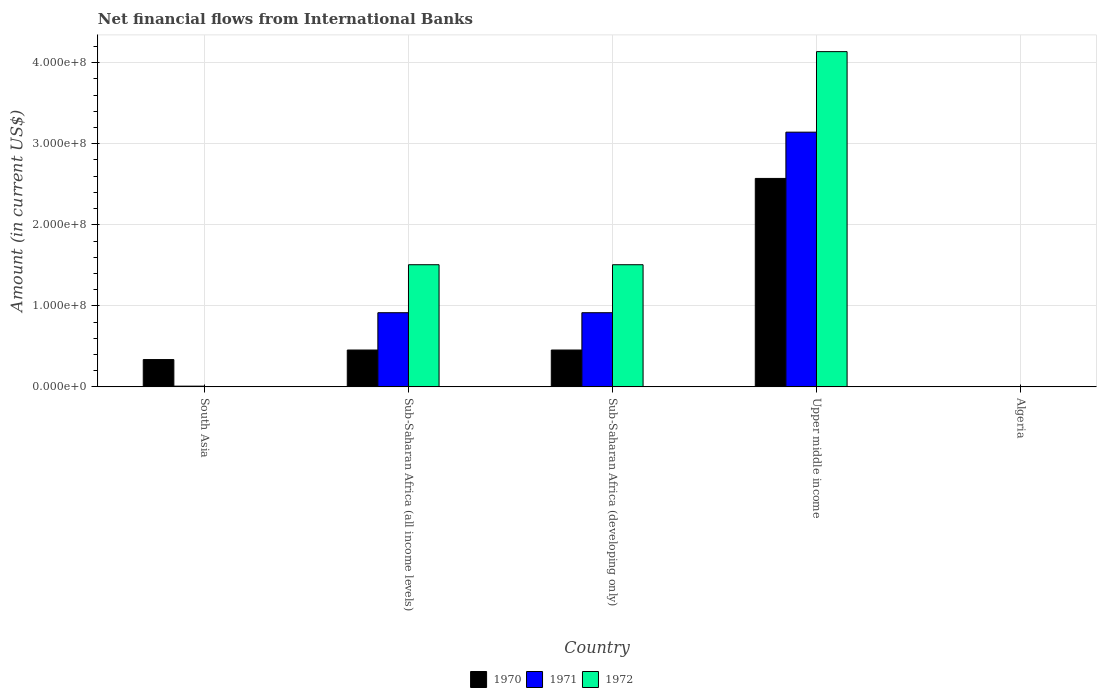How many different coloured bars are there?
Give a very brief answer. 3. Are the number of bars on each tick of the X-axis equal?
Provide a succinct answer. No. How many bars are there on the 1st tick from the left?
Offer a terse response. 2. How many bars are there on the 1st tick from the right?
Your response must be concise. 0. What is the label of the 4th group of bars from the left?
Your answer should be compact. Upper middle income. What is the net financial aid flows in 1971 in Algeria?
Ensure brevity in your answer.  0. Across all countries, what is the maximum net financial aid flows in 1972?
Make the answer very short. 4.14e+08. In which country was the net financial aid flows in 1971 maximum?
Provide a short and direct response. Upper middle income. What is the total net financial aid flows in 1972 in the graph?
Offer a terse response. 7.15e+08. What is the difference between the net financial aid flows in 1970 in South Asia and that in Sub-Saharan Africa (all income levels)?
Give a very brief answer. -1.18e+07. What is the difference between the net financial aid flows in 1970 in Algeria and the net financial aid flows in 1971 in Sub-Saharan Africa (developing only)?
Make the answer very short. -9.15e+07. What is the average net financial aid flows in 1970 per country?
Your answer should be compact. 7.64e+07. What is the difference between the net financial aid flows of/in 1971 and net financial aid flows of/in 1972 in Sub-Saharan Africa (all income levels)?
Offer a very short reply. -5.92e+07. What is the ratio of the net financial aid flows in 1972 in Sub-Saharan Africa (all income levels) to that in Upper middle income?
Provide a succinct answer. 0.36. What is the difference between the highest and the second highest net financial aid flows in 1972?
Offer a very short reply. 2.63e+08. What is the difference between the highest and the lowest net financial aid flows in 1972?
Provide a succinct answer. 4.14e+08. Is it the case that in every country, the sum of the net financial aid flows in 1970 and net financial aid flows in 1971 is greater than the net financial aid flows in 1972?
Your answer should be compact. No. How many bars are there?
Your answer should be compact. 11. Are all the bars in the graph horizontal?
Offer a very short reply. No. What is the difference between two consecutive major ticks on the Y-axis?
Ensure brevity in your answer.  1.00e+08. Are the values on the major ticks of Y-axis written in scientific E-notation?
Offer a very short reply. Yes. Where does the legend appear in the graph?
Offer a very short reply. Bottom center. How are the legend labels stacked?
Ensure brevity in your answer.  Horizontal. What is the title of the graph?
Make the answer very short. Net financial flows from International Banks. Does "1973" appear as one of the legend labels in the graph?
Ensure brevity in your answer.  No. What is the label or title of the Y-axis?
Keep it short and to the point. Amount (in current US$). What is the Amount (in current US$) of 1970 in South Asia?
Provide a succinct answer. 3.37e+07. What is the Amount (in current US$) of 1971 in South Asia?
Your answer should be very brief. 8.91e+05. What is the Amount (in current US$) in 1970 in Sub-Saharan Africa (all income levels)?
Provide a succinct answer. 4.55e+07. What is the Amount (in current US$) of 1971 in Sub-Saharan Africa (all income levels)?
Offer a very short reply. 9.15e+07. What is the Amount (in current US$) in 1972 in Sub-Saharan Africa (all income levels)?
Make the answer very short. 1.51e+08. What is the Amount (in current US$) in 1970 in Sub-Saharan Africa (developing only)?
Your response must be concise. 4.55e+07. What is the Amount (in current US$) of 1971 in Sub-Saharan Africa (developing only)?
Keep it short and to the point. 9.15e+07. What is the Amount (in current US$) of 1972 in Sub-Saharan Africa (developing only)?
Your answer should be compact. 1.51e+08. What is the Amount (in current US$) in 1970 in Upper middle income?
Give a very brief answer. 2.57e+08. What is the Amount (in current US$) in 1971 in Upper middle income?
Your response must be concise. 3.14e+08. What is the Amount (in current US$) in 1972 in Upper middle income?
Your response must be concise. 4.14e+08. Across all countries, what is the maximum Amount (in current US$) in 1970?
Give a very brief answer. 2.57e+08. Across all countries, what is the maximum Amount (in current US$) in 1971?
Your answer should be very brief. 3.14e+08. Across all countries, what is the maximum Amount (in current US$) of 1972?
Provide a succinct answer. 4.14e+08. What is the total Amount (in current US$) in 1970 in the graph?
Your response must be concise. 3.82e+08. What is the total Amount (in current US$) of 1971 in the graph?
Your response must be concise. 4.98e+08. What is the total Amount (in current US$) in 1972 in the graph?
Offer a terse response. 7.15e+08. What is the difference between the Amount (in current US$) in 1970 in South Asia and that in Sub-Saharan Africa (all income levels)?
Provide a short and direct response. -1.18e+07. What is the difference between the Amount (in current US$) in 1971 in South Asia and that in Sub-Saharan Africa (all income levels)?
Make the answer very short. -9.06e+07. What is the difference between the Amount (in current US$) in 1970 in South Asia and that in Sub-Saharan Africa (developing only)?
Your response must be concise. -1.18e+07. What is the difference between the Amount (in current US$) in 1971 in South Asia and that in Sub-Saharan Africa (developing only)?
Offer a terse response. -9.06e+07. What is the difference between the Amount (in current US$) of 1970 in South Asia and that in Upper middle income?
Offer a very short reply. -2.24e+08. What is the difference between the Amount (in current US$) in 1971 in South Asia and that in Upper middle income?
Offer a very short reply. -3.13e+08. What is the difference between the Amount (in current US$) of 1970 in Sub-Saharan Africa (all income levels) and that in Sub-Saharan Africa (developing only)?
Your answer should be very brief. 0. What is the difference between the Amount (in current US$) of 1971 in Sub-Saharan Africa (all income levels) and that in Sub-Saharan Africa (developing only)?
Offer a very short reply. 0. What is the difference between the Amount (in current US$) in 1972 in Sub-Saharan Africa (all income levels) and that in Sub-Saharan Africa (developing only)?
Provide a short and direct response. 0. What is the difference between the Amount (in current US$) in 1970 in Sub-Saharan Africa (all income levels) and that in Upper middle income?
Your answer should be compact. -2.12e+08. What is the difference between the Amount (in current US$) in 1971 in Sub-Saharan Africa (all income levels) and that in Upper middle income?
Your response must be concise. -2.23e+08. What is the difference between the Amount (in current US$) of 1972 in Sub-Saharan Africa (all income levels) and that in Upper middle income?
Give a very brief answer. -2.63e+08. What is the difference between the Amount (in current US$) of 1970 in Sub-Saharan Africa (developing only) and that in Upper middle income?
Your answer should be compact. -2.12e+08. What is the difference between the Amount (in current US$) of 1971 in Sub-Saharan Africa (developing only) and that in Upper middle income?
Ensure brevity in your answer.  -2.23e+08. What is the difference between the Amount (in current US$) of 1972 in Sub-Saharan Africa (developing only) and that in Upper middle income?
Offer a very short reply. -2.63e+08. What is the difference between the Amount (in current US$) in 1970 in South Asia and the Amount (in current US$) in 1971 in Sub-Saharan Africa (all income levels)?
Keep it short and to the point. -5.78e+07. What is the difference between the Amount (in current US$) of 1970 in South Asia and the Amount (in current US$) of 1972 in Sub-Saharan Africa (all income levels)?
Give a very brief answer. -1.17e+08. What is the difference between the Amount (in current US$) of 1971 in South Asia and the Amount (in current US$) of 1972 in Sub-Saharan Africa (all income levels)?
Your response must be concise. -1.50e+08. What is the difference between the Amount (in current US$) of 1970 in South Asia and the Amount (in current US$) of 1971 in Sub-Saharan Africa (developing only)?
Provide a short and direct response. -5.78e+07. What is the difference between the Amount (in current US$) of 1970 in South Asia and the Amount (in current US$) of 1972 in Sub-Saharan Africa (developing only)?
Your answer should be very brief. -1.17e+08. What is the difference between the Amount (in current US$) of 1971 in South Asia and the Amount (in current US$) of 1972 in Sub-Saharan Africa (developing only)?
Keep it short and to the point. -1.50e+08. What is the difference between the Amount (in current US$) of 1970 in South Asia and the Amount (in current US$) of 1971 in Upper middle income?
Make the answer very short. -2.81e+08. What is the difference between the Amount (in current US$) in 1970 in South Asia and the Amount (in current US$) in 1972 in Upper middle income?
Make the answer very short. -3.80e+08. What is the difference between the Amount (in current US$) in 1971 in South Asia and the Amount (in current US$) in 1972 in Upper middle income?
Your answer should be very brief. -4.13e+08. What is the difference between the Amount (in current US$) of 1970 in Sub-Saharan Africa (all income levels) and the Amount (in current US$) of 1971 in Sub-Saharan Africa (developing only)?
Your response must be concise. -4.61e+07. What is the difference between the Amount (in current US$) of 1970 in Sub-Saharan Africa (all income levels) and the Amount (in current US$) of 1972 in Sub-Saharan Africa (developing only)?
Keep it short and to the point. -1.05e+08. What is the difference between the Amount (in current US$) of 1971 in Sub-Saharan Africa (all income levels) and the Amount (in current US$) of 1972 in Sub-Saharan Africa (developing only)?
Make the answer very short. -5.92e+07. What is the difference between the Amount (in current US$) of 1970 in Sub-Saharan Africa (all income levels) and the Amount (in current US$) of 1971 in Upper middle income?
Your response must be concise. -2.69e+08. What is the difference between the Amount (in current US$) in 1970 in Sub-Saharan Africa (all income levels) and the Amount (in current US$) in 1972 in Upper middle income?
Keep it short and to the point. -3.68e+08. What is the difference between the Amount (in current US$) of 1971 in Sub-Saharan Africa (all income levels) and the Amount (in current US$) of 1972 in Upper middle income?
Provide a short and direct response. -3.22e+08. What is the difference between the Amount (in current US$) of 1970 in Sub-Saharan Africa (developing only) and the Amount (in current US$) of 1971 in Upper middle income?
Your response must be concise. -2.69e+08. What is the difference between the Amount (in current US$) in 1970 in Sub-Saharan Africa (developing only) and the Amount (in current US$) in 1972 in Upper middle income?
Your answer should be compact. -3.68e+08. What is the difference between the Amount (in current US$) of 1971 in Sub-Saharan Africa (developing only) and the Amount (in current US$) of 1972 in Upper middle income?
Offer a terse response. -3.22e+08. What is the average Amount (in current US$) of 1970 per country?
Your response must be concise. 7.64e+07. What is the average Amount (in current US$) of 1971 per country?
Your answer should be very brief. 9.97e+07. What is the average Amount (in current US$) in 1972 per country?
Your response must be concise. 1.43e+08. What is the difference between the Amount (in current US$) of 1970 and Amount (in current US$) of 1971 in South Asia?
Keep it short and to the point. 3.28e+07. What is the difference between the Amount (in current US$) of 1970 and Amount (in current US$) of 1971 in Sub-Saharan Africa (all income levels)?
Your answer should be compact. -4.61e+07. What is the difference between the Amount (in current US$) of 1970 and Amount (in current US$) of 1972 in Sub-Saharan Africa (all income levels)?
Offer a terse response. -1.05e+08. What is the difference between the Amount (in current US$) of 1971 and Amount (in current US$) of 1972 in Sub-Saharan Africa (all income levels)?
Provide a succinct answer. -5.92e+07. What is the difference between the Amount (in current US$) of 1970 and Amount (in current US$) of 1971 in Sub-Saharan Africa (developing only)?
Provide a short and direct response. -4.61e+07. What is the difference between the Amount (in current US$) of 1970 and Amount (in current US$) of 1972 in Sub-Saharan Africa (developing only)?
Your response must be concise. -1.05e+08. What is the difference between the Amount (in current US$) of 1971 and Amount (in current US$) of 1972 in Sub-Saharan Africa (developing only)?
Ensure brevity in your answer.  -5.92e+07. What is the difference between the Amount (in current US$) of 1970 and Amount (in current US$) of 1971 in Upper middle income?
Provide a succinct answer. -5.71e+07. What is the difference between the Amount (in current US$) in 1970 and Amount (in current US$) in 1972 in Upper middle income?
Your answer should be compact. -1.56e+08. What is the difference between the Amount (in current US$) in 1971 and Amount (in current US$) in 1972 in Upper middle income?
Your response must be concise. -9.94e+07. What is the ratio of the Amount (in current US$) of 1970 in South Asia to that in Sub-Saharan Africa (all income levels)?
Make the answer very short. 0.74. What is the ratio of the Amount (in current US$) of 1971 in South Asia to that in Sub-Saharan Africa (all income levels)?
Make the answer very short. 0.01. What is the ratio of the Amount (in current US$) of 1970 in South Asia to that in Sub-Saharan Africa (developing only)?
Make the answer very short. 0.74. What is the ratio of the Amount (in current US$) in 1971 in South Asia to that in Sub-Saharan Africa (developing only)?
Your answer should be compact. 0.01. What is the ratio of the Amount (in current US$) in 1970 in South Asia to that in Upper middle income?
Your answer should be compact. 0.13. What is the ratio of the Amount (in current US$) in 1971 in South Asia to that in Upper middle income?
Keep it short and to the point. 0. What is the ratio of the Amount (in current US$) in 1972 in Sub-Saharan Africa (all income levels) to that in Sub-Saharan Africa (developing only)?
Offer a very short reply. 1. What is the ratio of the Amount (in current US$) of 1970 in Sub-Saharan Africa (all income levels) to that in Upper middle income?
Keep it short and to the point. 0.18. What is the ratio of the Amount (in current US$) of 1971 in Sub-Saharan Africa (all income levels) to that in Upper middle income?
Your answer should be compact. 0.29. What is the ratio of the Amount (in current US$) in 1972 in Sub-Saharan Africa (all income levels) to that in Upper middle income?
Your response must be concise. 0.36. What is the ratio of the Amount (in current US$) of 1970 in Sub-Saharan Africa (developing only) to that in Upper middle income?
Your answer should be very brief. 0.18. What is the ratio of the Amount (in current US$) in 1971 in Sub-Saharan Africa (developing only) to that in Upper middle income?
Give a very brief answer. 0.29. What is the ratio of the Amount (in current US$) in 1972 in Sub-Saharan Africa (developing only) to that in Upper middle income?
Give a very brief answer. 0.36. What is the difference between the highest and the second highest Amount (in current US$) of 1970?
Provide a succinct answer. 2.12e+08. What is the difference between the highest and the second highest Amount (in current US$) of 1971?
Ensure brevity in your answer.  2.23e+08. What is the difference between the highest and the second highest Amount (in current US$) in 1972?
Your response must be concise. 2.63e+08. What is the difference between the highest and the lowest Amount (in current US$) of 1970?
Your response must be concise. 2.57e+08. What is the difference between the highest and the lowest Amount (in current US$) in 1971?
Ensure brevity in your answer.  3.14e+08. What is the difference between the highest and the lowest Amount (in current US$) in 1972?
Give a very brief answer. 4.14e+08. 